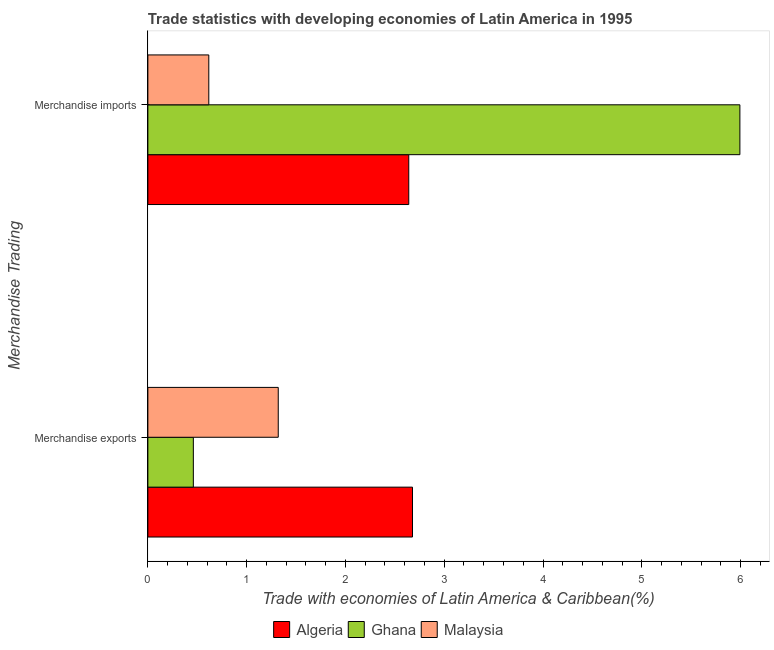How many groups of bars are there?
Give a very brief answer. 2. Are the number of bars per tick equal to the number of legend labels?
Keep it short and to the point. Yes. How many bars are there on the 2nd tick from the top?
Your answer should be very brief. 3. How many bars are there on the 1st tick from the bottom?
Make the answer very short. 3. What is the label of the 1st group of bars from the top?
Provide a short and direct response. Merchandise imports. What is the merchandise imports in Algeria?
Give a very brief answer. 2.64. Across all countries, what is the maximum merchandise exports?
Keep it short and to the point. 2.68. Across all countries, what is the minimum merchandise imports?
Make the answer very short. 0.62. In which country was the merchandise exports maximum?
Keep it short and to the point. Algeria. What is the total merchandise imports in the graph?
Give a very brief answer. 9.25. What is the difference between the merchandise imports in Algeria and that in Ghana?
Your answer should be very brief. -3.35. What is the difference between the merchandise exports in Ghana and the merchandise imports in Algeria?
Your response must be concise. -2.18. What is the average merchandise imports per country?
Make the answer very short. 3.08. What is the difference between the merchandise exports and merchandise imports in Algeria?
Make the answer very short. 0.04. What is the ratio of the merchandise exports in Algeria to that in Malaysia?
Offer a terse response. 2.03. In how many countries, is the merchandise imports greater than the average merchandise imports taken over all countries?
Provide a short and direct response. 1. What does the 1st bar from the top in Merchandise exports represents?
Ensure brevity in your answer.  Malaysia. What does the 3rd bar from the bottom in Merchandise exports represents?
Your answer should be very brief. Malaysia. Are all the bars in the graph horizontal?
Your response must be concise. Yes. How many countries are there in the graph?
Your answer should be very brief. 3. Are the values on the major ticks of X-axis written in scientific E-notation?
Your answer should be very brief. No. Does the graph contain any zero values?
Give a very brief answer. No. Where does the legend appear in the graph?
Offer a very short reply. Bottom center. How many legend labels are there?
Your answer should be very brief. 3. How are the legend labels stacked?
Offer a terse response. Horizontal. What is the title of the graph?
Ensure brevity in your answer.  Trade statistics with developing economies of Latin America in 1995. Does "Slovak Republic" appear as one of the legend labels in the graph?
Keep it short and to the point. No. What is the label or title of the X-axis?
Keep it short and to the point. Trade with economies of Latin America & Caribbean(%). What is the label or title of the Y-axis?
Your answer should be very brief. Merchandise Trading. What is the Trade with economies of Latin America & Caribbean(%) of Algeria in Merchandise exports?
Give a very brief answer. 2.68. What is the Trade with economies of Latin America & Caribbean(%) in Ghana in Merchandise exports?
Your response must be concise. 0.46. What is the Trade with economies of Latin America & Caribbean(%) of Malaysia in Merchandise exports?
Your response must be concise. 1.32. What is the Trade with economies of Latin America & Caribbean(%) of Algeria in Merchandise imports?
Give a very brief answer. 2.64. What is the Trade with economies of Latin America & Caribbean(%) of Ghana in Merchandise imports?
Provide a short and direct response. 5.99. What is the Trade with economies of Latin America & Caribbean(%) of Malaysia in Merchandise imports?
Offer a terse response. 0.62. Across all Merchandise Trading, what is the maximum Trade with economies of Latin America & Caribbean(%) of Algeria?
Provide a succinct answer. 2.68. Across all Merchandise Trading, what is the maximum Trade with economies of Latin America & Caribbean(%) in Ghana?
Offer a very short reply. 5.99. Across all Merchandise Trading, what is the maximum Trade with economies of Latin America & Caribbean(%) of Malaysia?
Your answer should be very brief. 1.32. Across all Merchandise Trading, what is the minimum Trade with economies of Latin America & Caribbean(%) in Algeria?
Provide a succinct answer. 2.64. Across all Merchandise Trading, what is the minimum Trade with economies of Latin America & Caribbean(%) of Ghana?
Your answer should be very brief. 0.46. Across all Merchandise Trading, what is the minimum Trade with economies of Latin America & Caribbean(%) of Malaysia?
Make the answer very short. 0.62. What is the total Trade with economies of Latin America & Caribbean(%) of Algeria in the graph?
Your answer should be very brief. 5.32. What is the total Trade with economies of Latin America & Caribbean(%) in Ghana in the graph?
Provide a succinct answer. 6.45. What is the total Trade with economies of Latin America & Caribbean(%) of Malaysia in the graph?
Provide a succinct answer. 1.94. What is the difference between the Trade with economies of Latin America & Caribbean(%) in Algeria in Merchandise exports and that in Merchandise imports?
Keep it short and to the point. 0.04. What is the difference between the Trade with economies of Latin America & Caribbean(%) of Ghana in Merchandise exports and that in Merchandise imports?
Provide a short and direct response. -5.53. What is the difference between the Trade with economies of Latin America & Caribbean(%) in Malaysia in Merchandise exports and that in Merchandise imports?
Your answer should be very brief. 0.7. What is the difference between the Trade with economies of Latin America & Caribbean(%) in Algeria in Merchandise exports and the Trade with economies of Latin America & Caribbean(%) in Ghana in Merchandise imports?
Your response must be concise. -3.31. What is the difference between the Trade with economies of Latin America & Caribbean(%) in Algeria in Merchandise exports and the Trade with economies of Latin America & Caribbean(%) in Malaysia in Merchandise imports?
Provide a short and direct response. 2.06. What is the difference between the Trade with economies of Latin America & Caribbean(%) in Ghana in Merchandise exports and the Trade with economies of Latin America & Caribbean(%) in Malaysia in Merchandise imports?
Give a very brief answer. -0.16. What is the average Trade with economies of Latin America & Caribbean(%) in Algeria per Merchandise Trading?
Ensure brevity in your answer.  2.66. What is the average Trade with economies of Latin America & Caribbean(%) of Ghana per Merchandise Trading?
Offer a very short reply. 3.23. What is the average Trade with economies of Latin America & Caribbean(%) in Malaysia per Merchandise Trading?
Offer a very short reply. 0.97. What is the difference between the Trade with economies of Latin America & Caribbean(%) in Algeria and Trade with economies of Latin America & Caribbean(%) in Ghana in Merchandise exports?
Make the answer very short. 2.22. What is the difference between the Trade with economies of Latin America & Caribbean(%) of Algeria and Trade with economies of Latin America & Caribbean(%) of Malaysia in Merchandise exports?
Give a very brief answer. 1.36. What is the difference between the Trade with economies of Latin America & Caribbean(%) of Ghana and Trade with economies of Latin America & Caribbean(%) of Malaysia in Merchandise exports?
Keep it short and to the point. -0.86. What is the difference between the Trade with economies of Latin America & Caribbean(%) in Algeria and Trade with economies of Latin America & Caribbean(%) in Ghana in Merchandise imports?
Ensure brevity in your answer.  -3.35. What is the difference between the Trade with economies of Latin America & Caribbean(%) in Algeria and Trade with economies of Latin America & Caribbean(%) in Malaysia in Merchandise imports?
Your answer should be compact. 2.02. What is the difference between the Trade with economies of Latin America & Caribbean(%) of Ghana and Trade with economies of Latin America & Caribbean(%) of Malaysia in Merchandise imports?
Provide a succinct answer. 5.38. What is the ratio of the Trade with economies of Latin America & Caribbean(%) in Algeria in Merchandise exports to that in Merchandise imports?
Ensure brevity in your answer.  1.01. What is the ratio of the Trade with economies of Latin America & Caribbean(%) in Ghana in Merchandise exports to that in Merchandise imports?
Your answer should be compact. 0.08. What is the ratio of the Trade with economies of Latin America & Caribbean(%) of Malaysia in Merchandise exports to that in Merchandise imports?
Offer a terse response. 2.14. What is the difference between the highest and the second highest Trade with economies of Latin America & Caribbean(%) of Algeria?
Make the answer very short. 0.04. What is the difference between the highest and the second highest Trade with economies of Latin America & Caribbean(%) of Ghana?
Ensure brevity in your answer.  5.53. What is the difference between the highest and the second highest Trade with economies of Latin America & Caribbean(%) in Malaysia?
Your answer should be very brief. 0.7. What is the difference between the highest and the lowest Trade with economies of Latin America & Caribbean(%) of Algeria?
Keep it short and to the point. 0.04. What is the difference between the highest and the lowest Trade with economies of Latin America & Caribbean(%) in Ghana?
Offer a very short reply. 5.53. What is the difference between the highest and the lowest Trade with economies of Latin America & Caribbean(%) of Malaysia?
Your answer should be very brief. 0.7. 